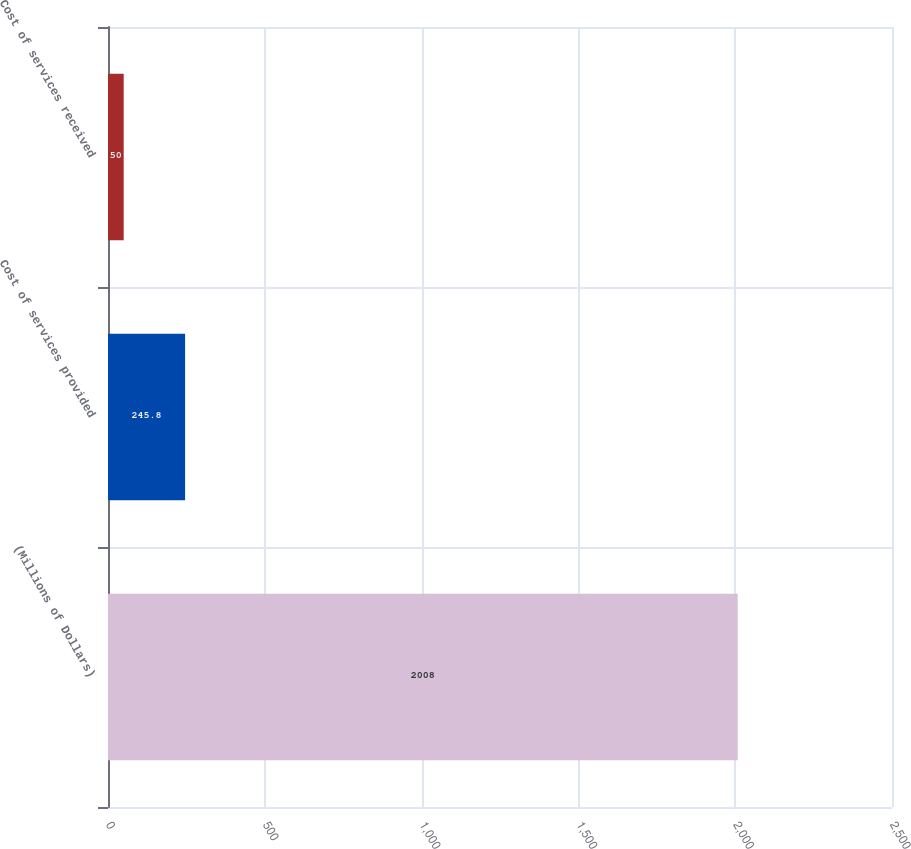Convert chart to OTSL. <chart><loc_0><loc_0><loc_500><loc_500><bar_chart><fcel>(Millions of Dollars)<fcel>Cost of services provided<fcel>Cost of services received<nl><fcel>2008<fcel>245.8<fcel>50<nl></chart> 